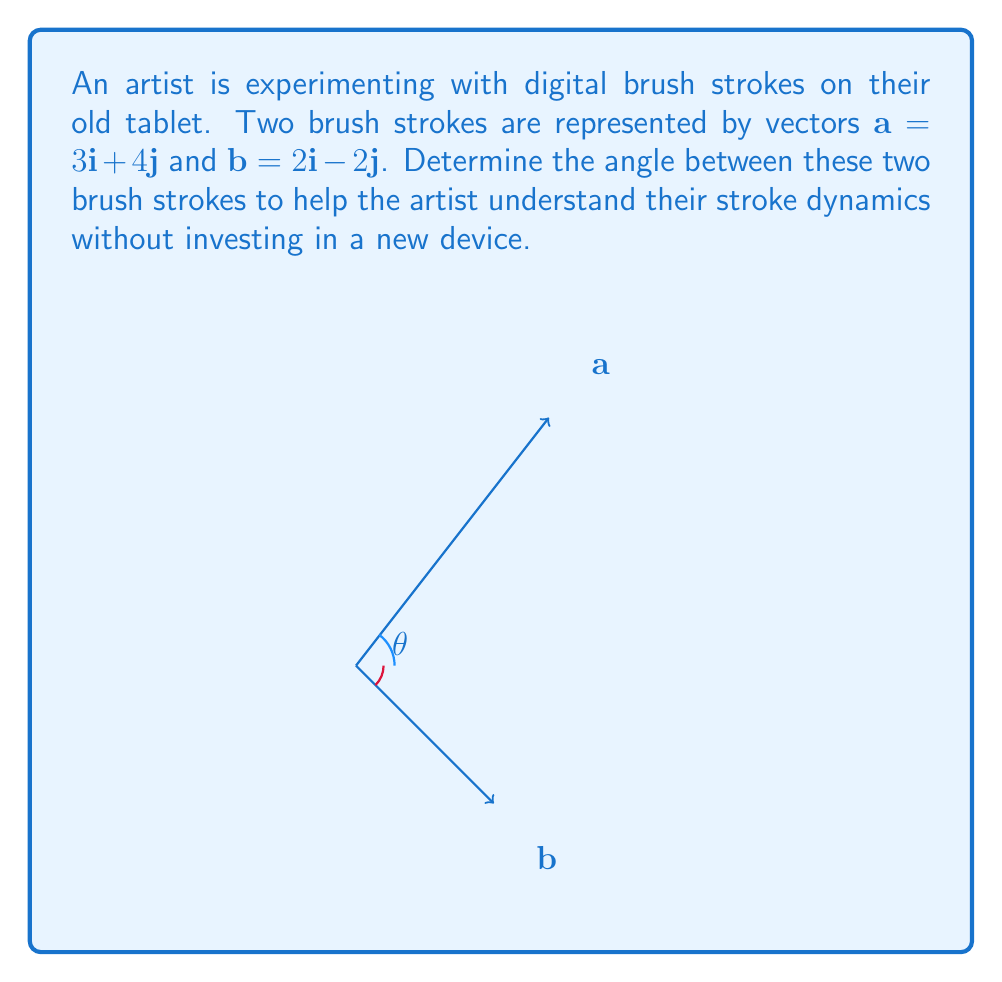Show me your answer to this math problem. To find the angle between two vectors, we can use the dot product formula:

$$\cos \theta = \frac{\mathbf{a} \cdot \mathbf{b}}{|\mathbf{a}||\mathbf{b}|}$$

Step 1: Calculate the dot product $\mathbf{a} \cdot \mathbf{b}$
$$\mathbf{a} \cdot \mathbf{b} = (3)(2) + (4)(-2) = 6 - 8 = -2$$

Step 2: Calculate the magnitudes of $\mathbf{a}$ and $\mathbf{b}$
$$|\mathbf{a}| = \sqrt{3^2 + 4^2} = \sqrt{9 + 16} = \sqrt{25} = 5$$
$$|\mathbf{b}| = \sqrt{2^2 + (-2)^2} = \sqrt{4 + 4} = \sqrt{8} = 2\sqrt{2}$$

Step 3: Substitute into the formula
$$\cos \theta = \frac{-2}{5(2\sqrt{2})} = \frac{-1}{5\sqrt{2}}$$

Step 4: Take the inverse cosine (arccos) of both sides
$$\theta = \arccos\left(\frac{-1}{5\sqrt{2}}\right)$$

Step 5: Calculate the result (approximately)
$$\theta \approx 2.0344 \text{ radians} \approx 116.57°$$
Answer: $\arccos\left(\frac{-1}{5\sqrt{2}}\right) \approx 116.57°$ 